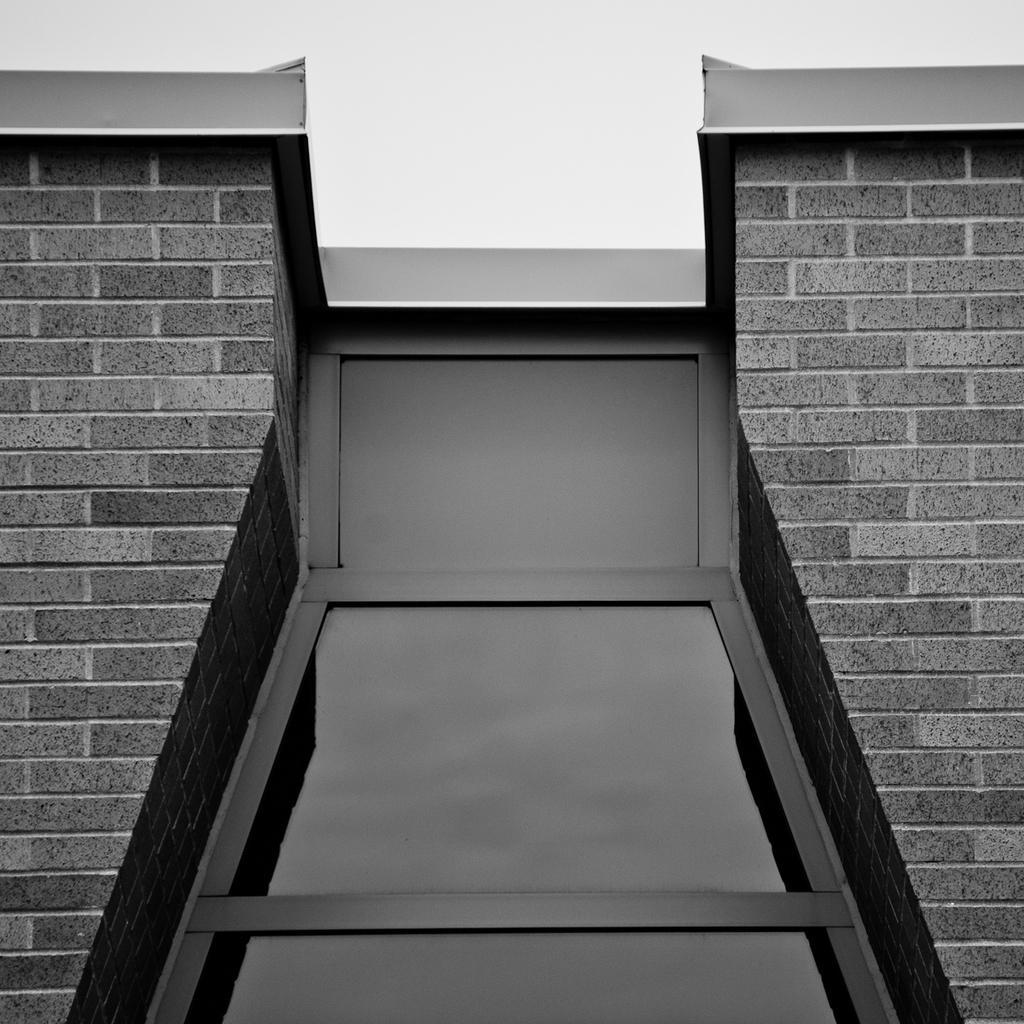How would you summarize this image in a sentence or two? In this image there is a building. This is the sky. These are glasses. 